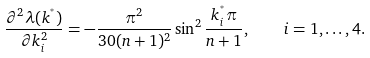<formula> <loc_0><loc_0><loc_500><loc_500>\frac { \partial ^ { 2 } \lambda ( k ^ { ^ { * } } ) } { \partial k _ { i } ^ { 2 } } = - \frac { \pi ^ { 2 } } { 3 0 ( n + 1 ) ^ { 2 } } \sin ^ { 2 } \frac { k _ { i } ^ { ^ { * } } \pi } { n + 1 } , \quad i = 1 , \dots , 4 .</formula> 